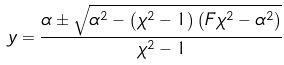<formula> <loc_0><loc_0><loc_500><loc_500>y = \frac { \alpha \pm \sqrt { \alpha ^ { 2 } - \left ( \chi ^ { 2 } - 1 \right ) \left ( F \chi ^ { 2 } - \alpha ^ { 2 } \right ) } } { \chi ^ { 2 } - 1 }</formula> 